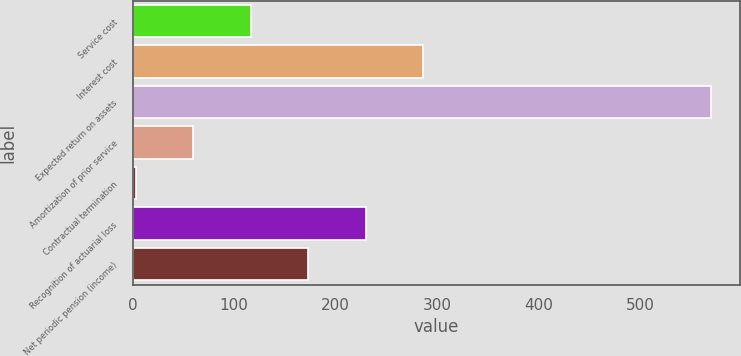Convert chart to OTSL. <chart><loc_0><loc_0><loc_500><loc_500><bar_chart><fcel>Service cost<fcel>Interest cost<fcel>Expected return on assets<fcel>Amortization of prior service<fcel>Contractual termination<fcel>Recognition of actuarial loss<fcel>Net periodic pension (income)<nl><fcel>116.4<fcel>286.5<fcel>570<fcel>59.7<fcel>3<fcel>229.8<fcel>173.1<nl></chart> 